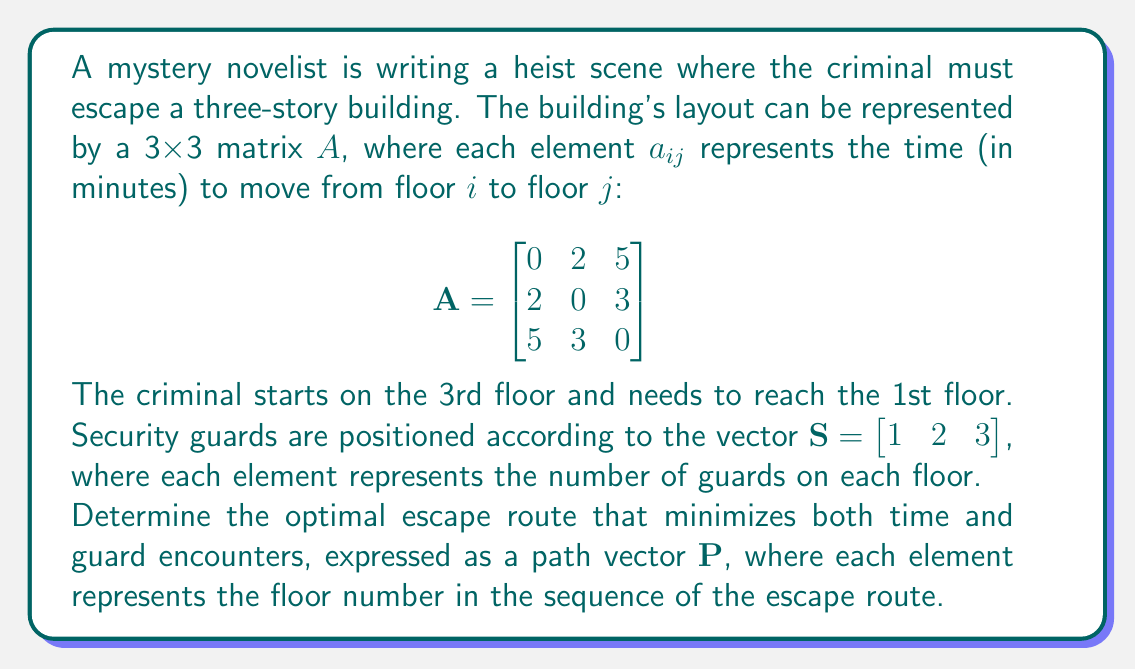Can you answer this question? To solve this problem, we need to consider both the time taken and the number of guards encountered. We'll approach this step-by-step:

1) First, let's consider all possible paths from the 3rd floor to the 1st floor:
   - 3 → 1
   - 3 → 2 → 1

2) Now, let's calculate the time for each path:
   - 3 → 1: 5 minutes
   - 3 → 2 → 1: 3 + 2 = 5 minutes

3) Both paths take the same amount of time, so we need to consider the number of guards encountered.

4) Let's calculate the total number of guards encountered for each path:
   - 3 → 1: 3 (3rd floor) + 1 (1st floor) = 4 guards
   - 3 → 2 → 1: 3 (3rd floor) + 2 (2nd floor) + 1 (1st floor) = 6 guards

5) The path 3 → 1 encounters fewer guards while taking the same amount of time.

Therefore, the optimal escape route is directly from the 3rd floor to the 1st floor.
Answer: The optimal escape route is represented by the path vector $P = \begin{bmatrix} 3 & 1 \end{bmatrix}$. 